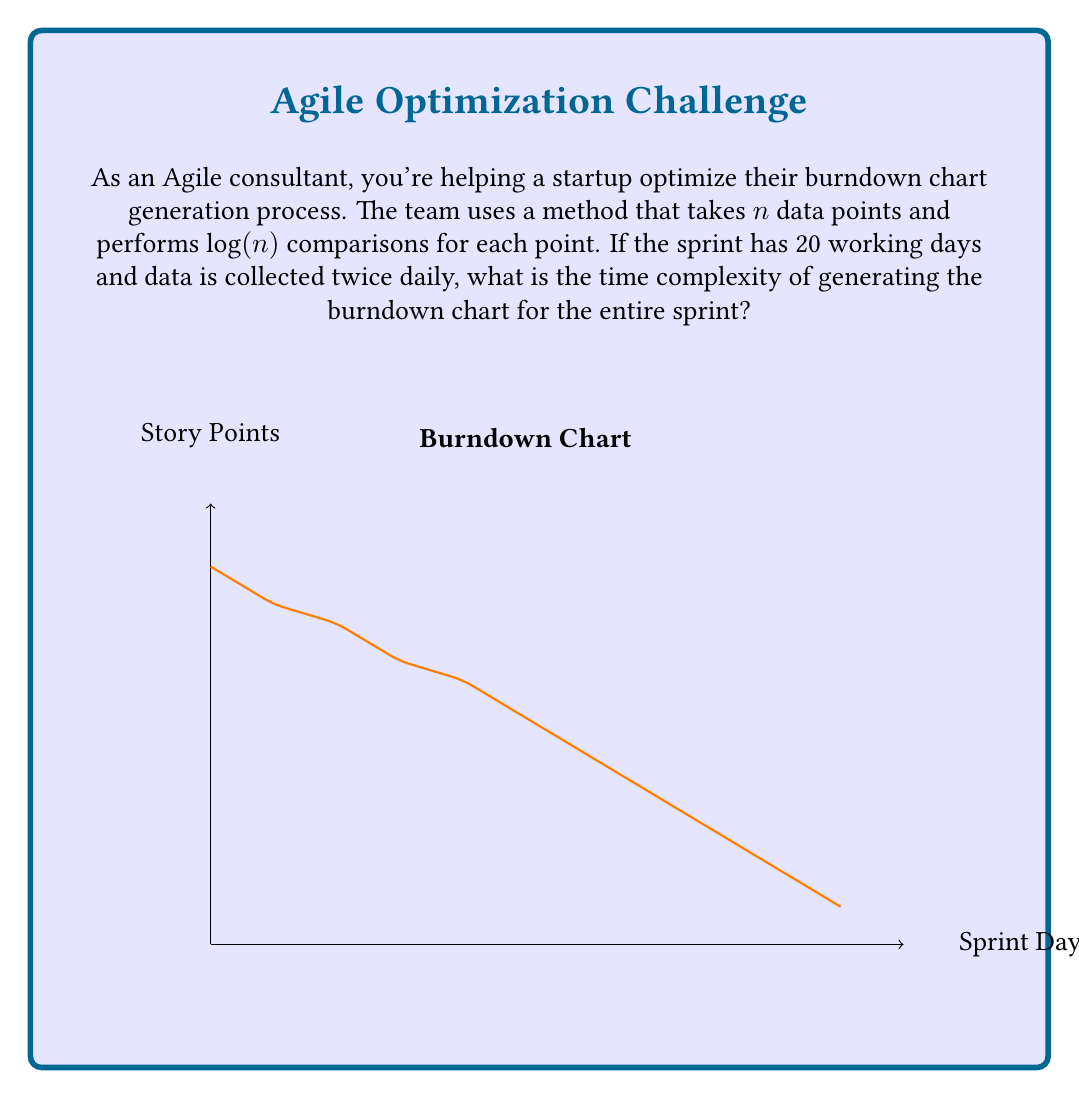Teach me how to tackle this problem. Let's approach this step-by-step:

1) First, we need to determine the number of data points ($n$):
   - There are 20 working days in the sprint
   - Data is collected twice daily
   - So, $n = 20 \times 2 = 40$ data points

2) For each data point, the method performs $\log(n)$ comparisons:
   - The number of comparisons per point is $\log(40)$

3) The total number of operations is the product of the number of points and the operations per point:
   - Total operations = $n \times \log(n) = 40 \times \log(40)$

4) In Big O notation, we express this as $O(n\log(n))$

5) The constant factors (40 in this case) are dropped in Big O notation, as we're interested in the growth rate as $n$ increases.

Therefore, the time complexity of generating the burndown chart for the entire sprint is $O(n\log(n))$.
Answer: $O(n\log(n))$ 